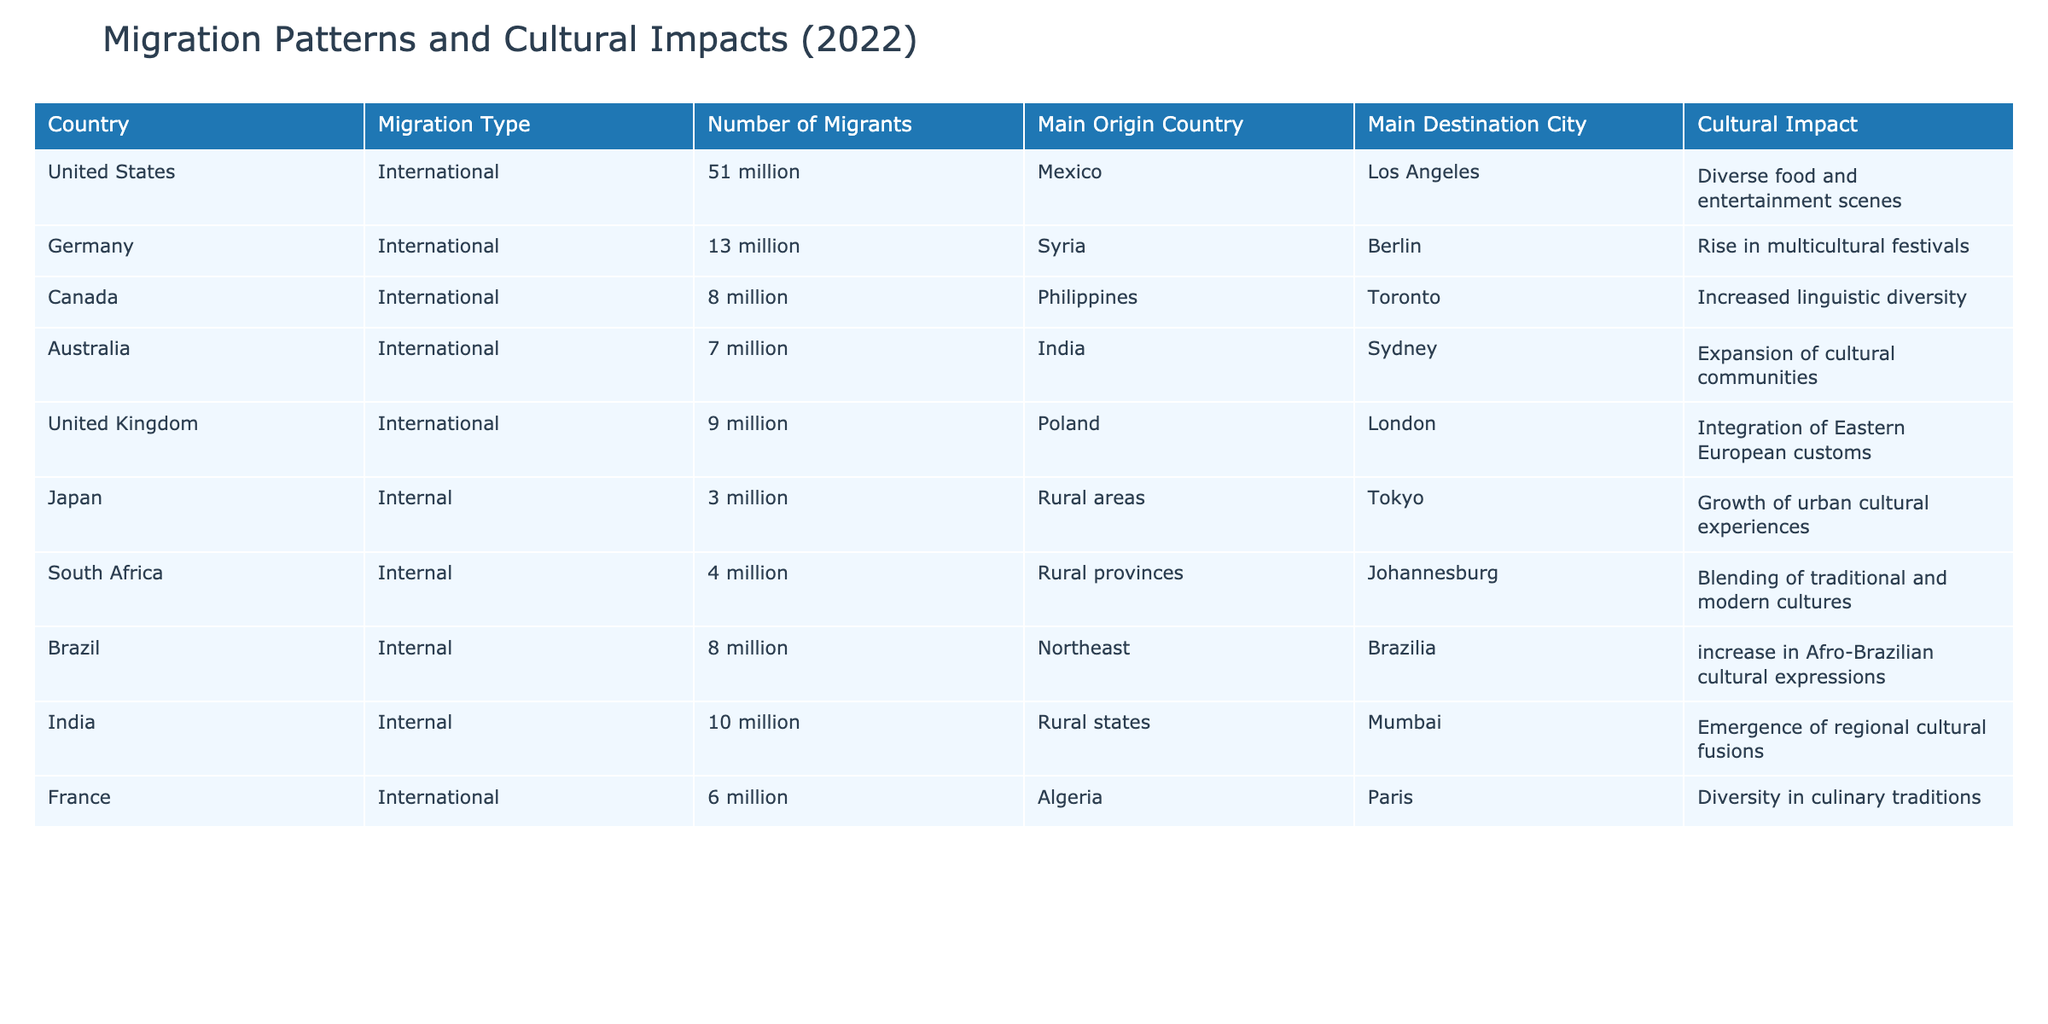What is the total number of international migrants? To find the total number of international migrants, we sum the "Number of Migrants" for all entries where "Migration Type" is "International." The values are 51 million (USA) + 13 million (Germany) + 8 million (Canada) + 7 million (Australia) + 9 million (UK) + 6 million (France) = 94 million.
Answer: 94 million Which country has the highest number of internal migrants? By looking at the "Number of Migrants" under "Internal" migration types, we can see that India has the highest number with 10 million, compared to 8 million (Brazil), 4 million (South Africa), and 3 million (Japan).
Answer: India Is the cultural impact of migration in Germany primarily due to international or internal migration? The table indicates that Germany's listed impact ("Rise in multicultural festivals") is linked specifically to "International" migrants, especially from Syria. Thus, the cultural impact is primarily due to international migration.
Answer: Yes How many countries listed have a cultural impact related to culinary traditions? We check the "Cultural Impact" column for mentions of culinary themes. Only France's entry explicitly states "Diversity in culinary traditions." Thus, one country is associated with culinary impacts.
Answer: 1 What is the difference in the number of internal migrants between Brazil and South Africa? To find the difference, we subtract the number of internal migrants in South Africa (4 million) from Brazil (8 million). The calculation is 8 million - 4 million = 4 million.
Answer: 4 million Which city is associated with the largest number of internal migrants? By examining the "Main Destination City" under "Internal" migration, Mumbai (India) has 10 million migrants, whereas the other respective cities have fewer. Therefore, Mumbai is associated with the largest number.
Answer: Mumbai Did the United States primarily receive migrants from the Caribbean? The main origin country of 51 million migrants to the United States is Mexico. Therefore, the statement is false as it does not mention the Caribbean.
Answer: No Overall, what is the average number of international migrants across the listed countries? To find the average for "International" migrants, we first sum them: 51 + 13 + 8 + 7 + 9 + 6 = 94 million. Then, we divide by the number of countries, which is 6. The average is 94 million / 6 = 15.67 million.
Answer: 15.67 million 